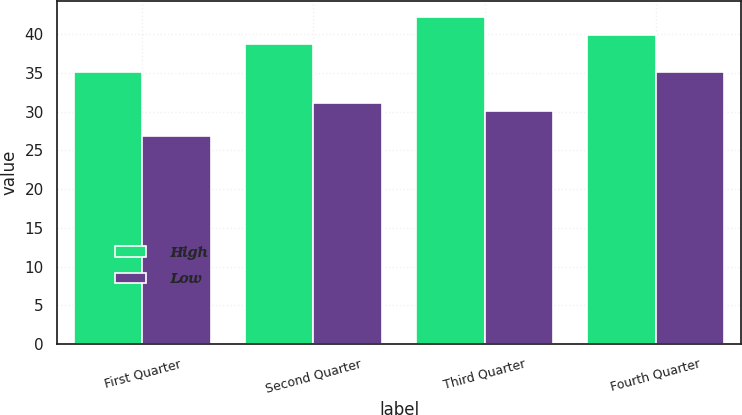<chart> <loc_0><loc_0><loc_500><loc_500><stacked_bar_chart><ecel><fcel>First Quarter<fcel>Second Quarter<fcel>Third Quarter<fcel>Fourth Quarter<nl><fcel>High<fcel>35.14<fcel>38.75<fcel>42.16<fcel>39.83<nl><fcel>Low<fcel>26.8<fcel>31.14<fcel>30.12<fcel>35.14<nl></chart> 